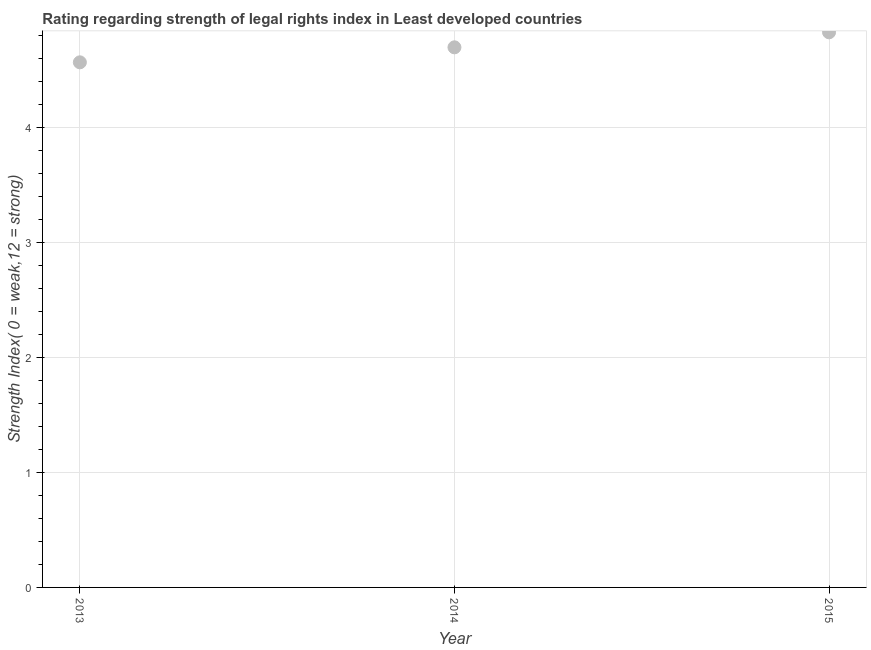What is the strength of legal rights index in 2015?
Your answer should be compact. 4.83. Across all years, what is the maximum strength of legal rights index?
Your answer should be very brief. 4.83. Across all years, what is the minimum strength of legal rights index?
Your response must be concise. 4.57. In which year was the strength of legal rights index maximum?
Your answer should be very brief. 2015. In which year was the strength of legal rights index minimum?
Ensure brevity in your answer.  2013. What is the sum of the strength of legal rights index?
Keep it short and to the point. 14.09. What is the difference between the strength of legal rights index in 2013 and 2014?
Your answer should be very brief. -0.13. What is the average strength of legal rights index per year?
Keep it short and to the point. 4.7. What is the median strength of legal rights index?
Offer a very short reply. 4.7. Do a majority of the years between 2015 and 2013 (inclusive) have strength of legal rights index greater than 1 ?
Your answer should be compact. No. What is the ratio of the strength of legal rights index in 2013 to that in 2015?
Ensure brevity in your answer.  0.95. Is the strength of legal rights index in 2013 less than that in 2014?
Provide a short and direct response. Yes. What is the difference between the highest and the second highest strength of legal rights index?
Your answer should be very brief. 0.13. Is the sum of the strength of legal rights index in 2013 and 2014 greater than the maximum strength of legal rights index across all years?
Keep it short and to the point. Yes. What is the difference between the highest and the lowest strength of legal rights index?
Keep it short and to the point. 0.26. Does the strength of legal rights index monotonically increase over the years?
Offer a terse response. Yes. How many dotlines are there?
Ensure brevity in your answer.  1. Are the values on the major ticks of Y-axis written in scientific E-notation?
Offer a terse response. No. Does the graph contain grids?
Keep it short and to the point. Yes. What is the title of the graph?
Ensure brevity in your answer.  Rating regarding strength of legal rights index in Least developed countries. What is the label or title of the Y-axis?
Provide a succinct answer. Strength Index( 0 = weak,12 = strong). What is the Strength Index( 0 = weak,12 = strong) in 2013?
Offer a terse response. 4.57. What is the Strength Index( 0 = weak,12 = strong) in 2014?
Make the answer very short. 4.7. What is the Strength Index( 0 = weak,12 = strong) in 2015?
Offer a very short reply. 4.83. What is the difference between the Strength Index( 0 = weak,12 = strong) in 2013 and 2014?
Ensure brevity in your answer.  -0.13. What is the difference between the Strength Index( 0 = weak,12 = strong) in 2013 and 2015?
Provide a short and direct response. -0.26. What is the difference between the Strength Index( 0 = weak,12 = strong) in 2014 and 2015?
Offer a very short reply. -0.13. What is the ratio of the Strength Index( 0 = weak,12 = strong) in 2013 to that in 2015?
Offer a terse response. 0.95. What is the ratio of the Strength Index( 0 = weak,12 = strong) in 2014 to that in 2015?
Offer a terse response. 0.97. 